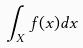<formula> <loc_0><loc_0><loc_500><loc_500>\int _ { X } f ( x ) d x</formula> 